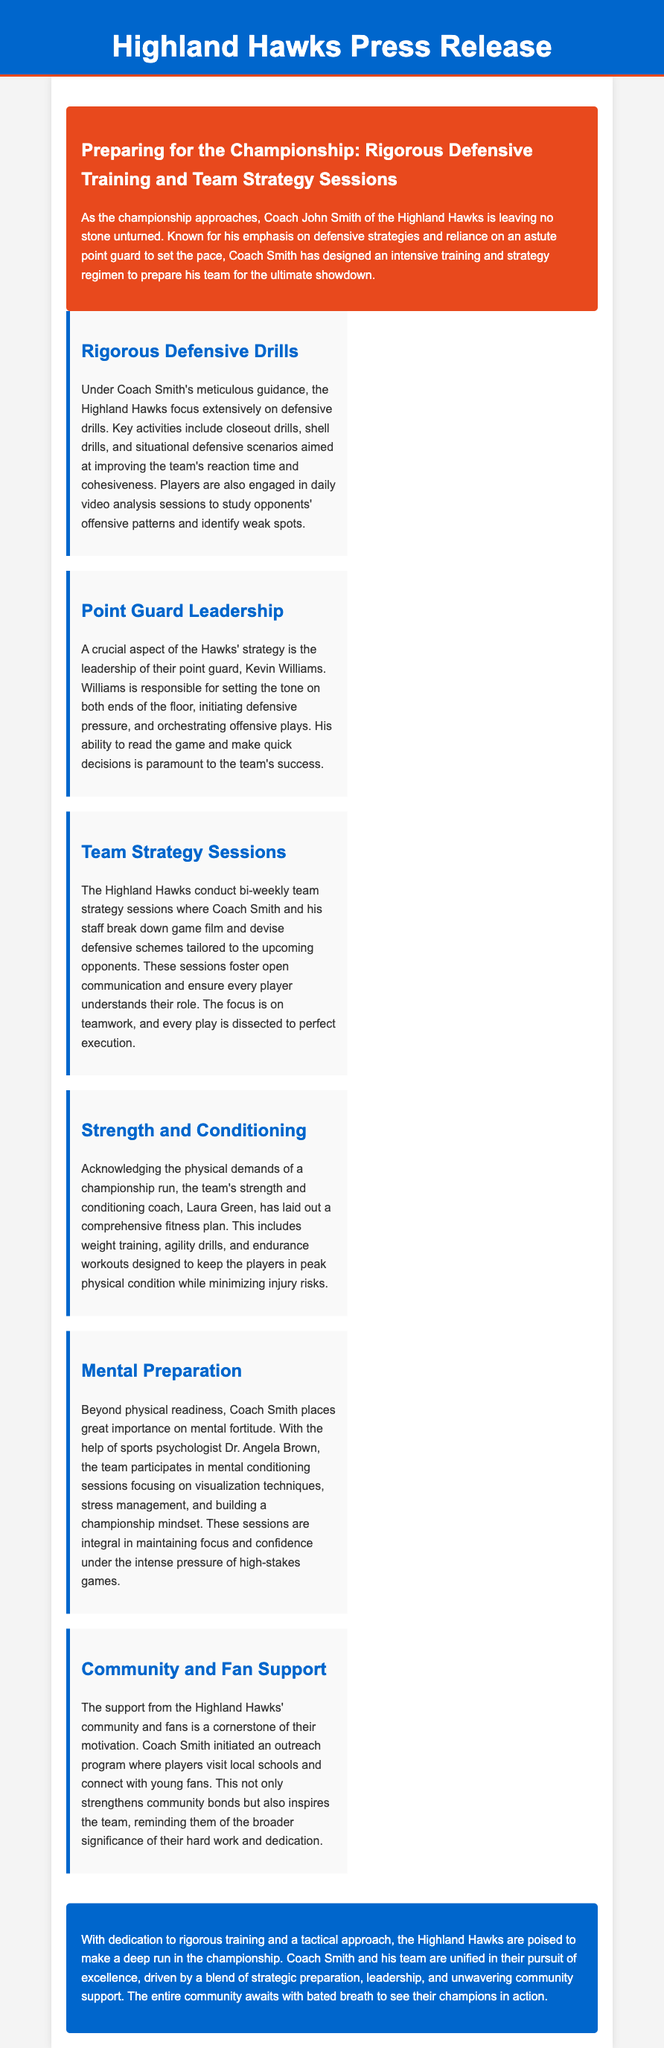what is the name of the head coach? The name of the head coach is mentioned in the introductory section as Coach John Smith.
Answer: Coach John Smith who is the point guard for the Highland Hawks? The point guard for the Highland Hawks is identified in the section about point guard leadership as Kevin Williams.
Answer: Kevin Williams what type of drills are emphasized in the defensive training? The drills emphasized include closeout drills, shell drills, and situational defensive scenarios, as stated in the section about rigorous defensive drills.
Answer: closeout drills, shell drills, situational defensive scenarios how often do the team strategy sessions occur? The frequency of the team strategy sessions is stated as bi-weekly in the section about team strategy sessions.
Answer: bi-weekly who assists with mental preparation for the team? The document mentions a sports psychologist, Dr. Angela Brown, who helps with mental preparation.
Answer: Dr. Angela Brown what is the role of Laura Green on the team? Laura Green is the strength and conditioning coach, as mentioned in the section about strength and conditioning.
Answer: strength and conditioning coach what is a key focus for the Hawks' community outreach program? The outreach program aims to connect players with local schools and young fans, as described in the community and fan support section.
Answer: connect players with local schools and young fans what is the main emphasis of Coach Smith's training strategy? The main emphasis of Coach Smith's training strategy is rigorous defensive training, as highlighted in the title and introduction of the press release.
Answer: rigorous defensive training 